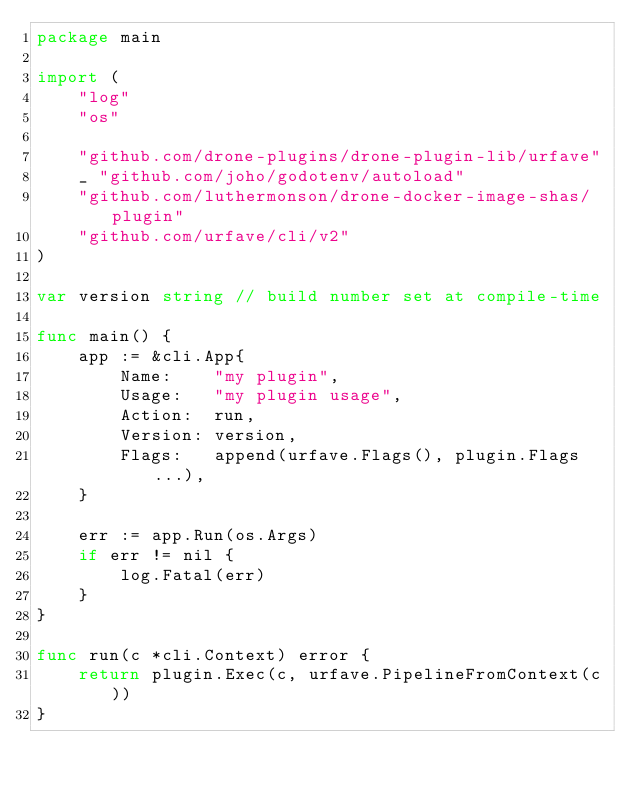Convert code to text. <code><loc_0><loc_0><loc_500><loc_500><_Go_>package main

import (
	"log"
	"os"

	"github.com/drone-plugins/drone-plugin-lib/urfave"
	_ "github.com/joho/godotenv/autoload"
	"github.com/luthermonson/drone-docker-image-shas/plugin"
	"github.com/urfave/cli/v2"
)

var version string // build number set at compile-time

func main() {
	app := &cli.App{
		Name:    "my plugin",
		Usage:   "my plugin usage",
		Action:  run,
		Version: version,
		Flags:   append(urfave.Flags(), plugin.Flags...),
	}

	err := app.Run(os.Args)
	if err != nil {
		log.Fatal(err)
	}
}

func run(c *cli.Context) error {
	return plugin.Exec(c, urfave.PipelineFromContext(c))
}
</code> 